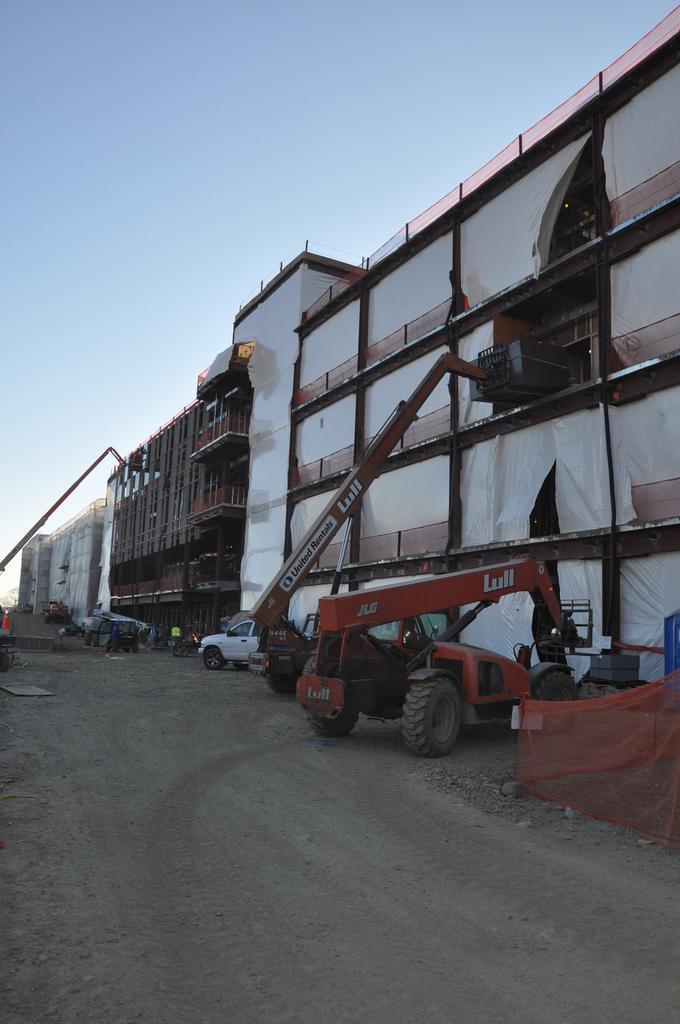Could you give a brief overview of what you see in this image? In this image we can see some buildings. We can also see some vehicles, some people, a traffic pole and the net on the pathway. On the backside we can see the sky which looks cloudy. 